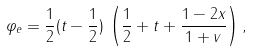Convert formula to latex. <formula><loc_0><loc_0><loc_500><loc_500>\varphi _ { e } = \frac { 1 } { 2 } ( t - \frac { 1 } { 2 } ) \, \left ( \frac { 1 } { 2 } + t + \frac { 1 - 2 x } { 1 + v } \right ) ,</formula> 